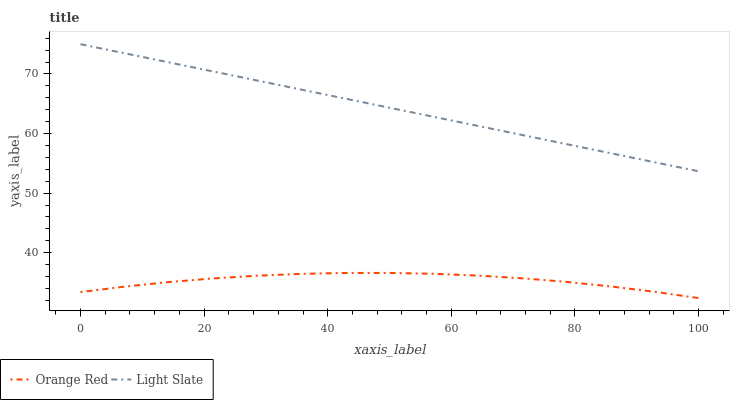Does Orange Red have the maximum area under the curve?
Answer yes or no. No. Is Orange Red the smoothest?
Answer yes or no. No. Does Orange Red have the highest value?
Answer yes or no. No. Is Orange Red less than Light Slate?
Answer yes or no. Yes. Is Light Slate greater than Orange Red?
Answer yes or no. Yes. Does Orange Red intersect Light Slate?
Answer yes or no. No. 